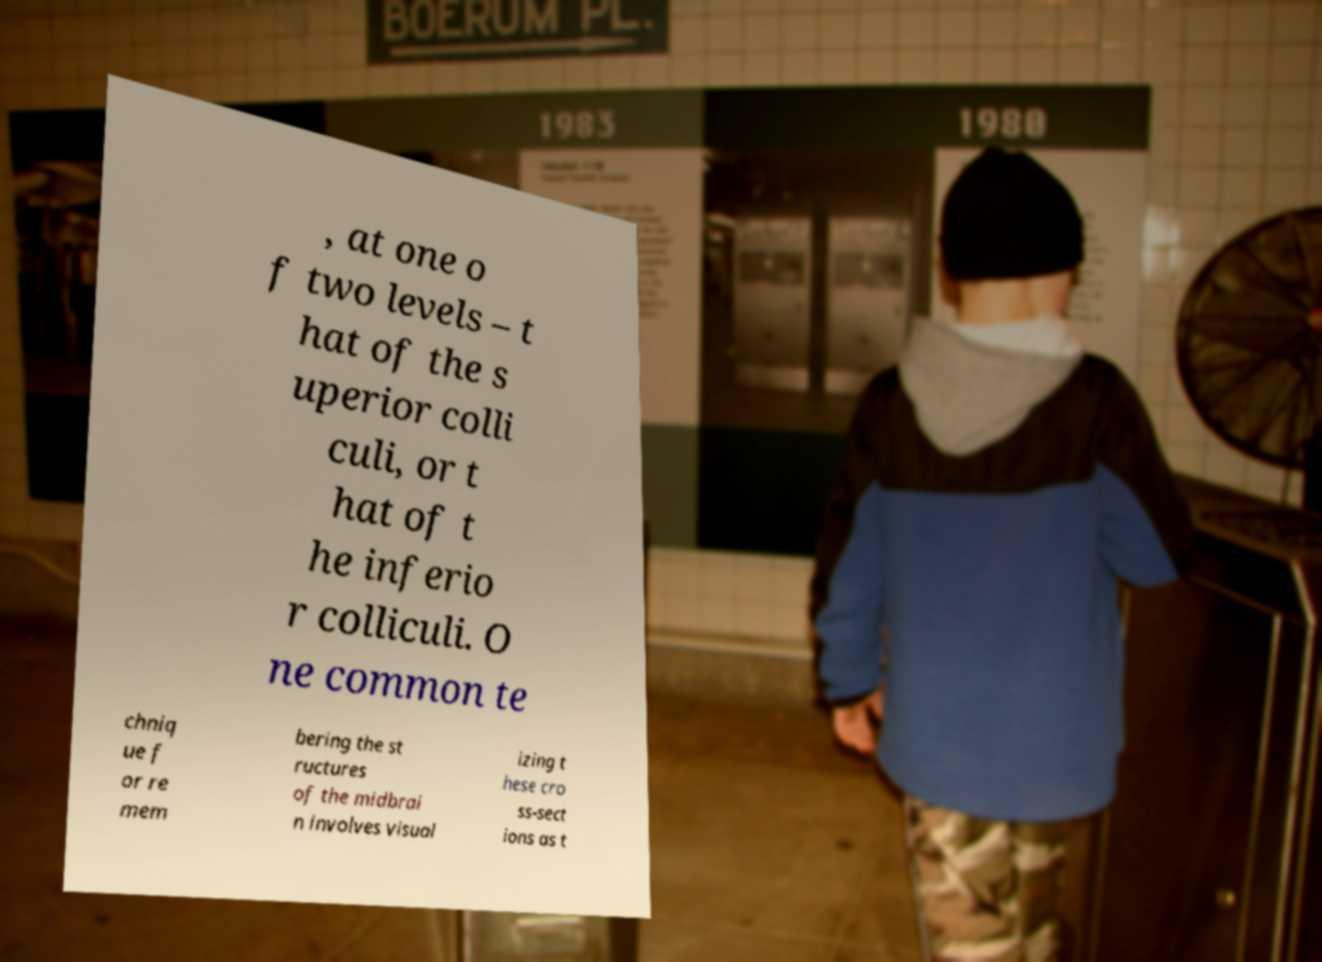There's text embedded in this image that I need extracted. Can you transcribe it verbatim? , at one o f two levels – t hat of the s uperior colli culi, or t hat of t he inferio r colliculi. O ne common te chniq ue f or re mem bering the st ructures of the midbrai n involves visual izing t hese cro ss-sect ions as t 